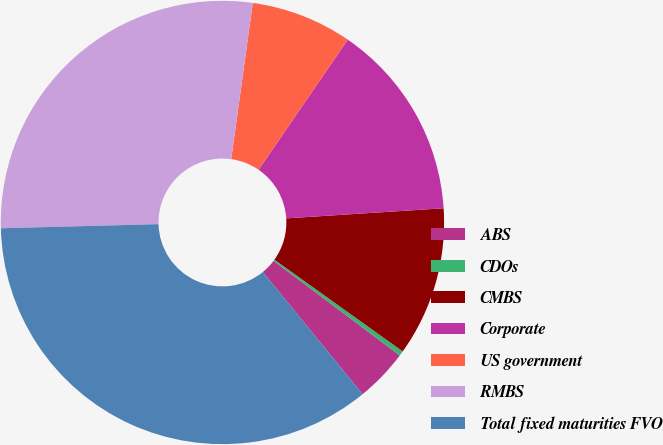<chart> <loc_0><loc_0><loc_500><loc_500><pie_chart><fcel>ABS<fcel>CDOs<fcel>CMBS<fcel>Corporate<fcel>US government<fcel>RMBS<fcel>Total fixed maturities FVO<nl><fcel>3.87%<fcel>0.36%<fcel>10.9%<fcel>14.41%<fcel>7.38%<fcel>27.6%<fcel>35.47%<nl></chart> 